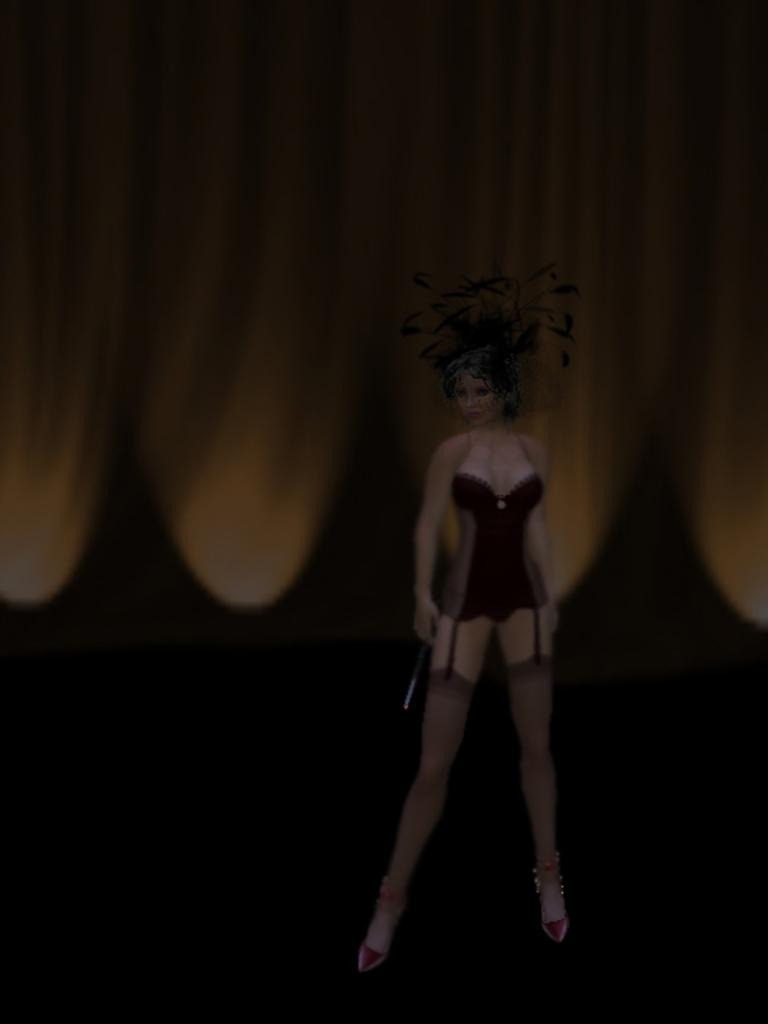What type of media is the image? The image is an animation. Who is the main subject in the image? There is a lady in the center of the image. What is the lady doing in the image? The lady is standing. What is the lady wearing in the image? The lady is wearing a costume. What type of berry is the lady holding in the image? There is no berry present in the image; the lady is wearing a costume. What does the lady's voice sound like in the image? The image is a still frame, so there is no sound or voice associated with it. 